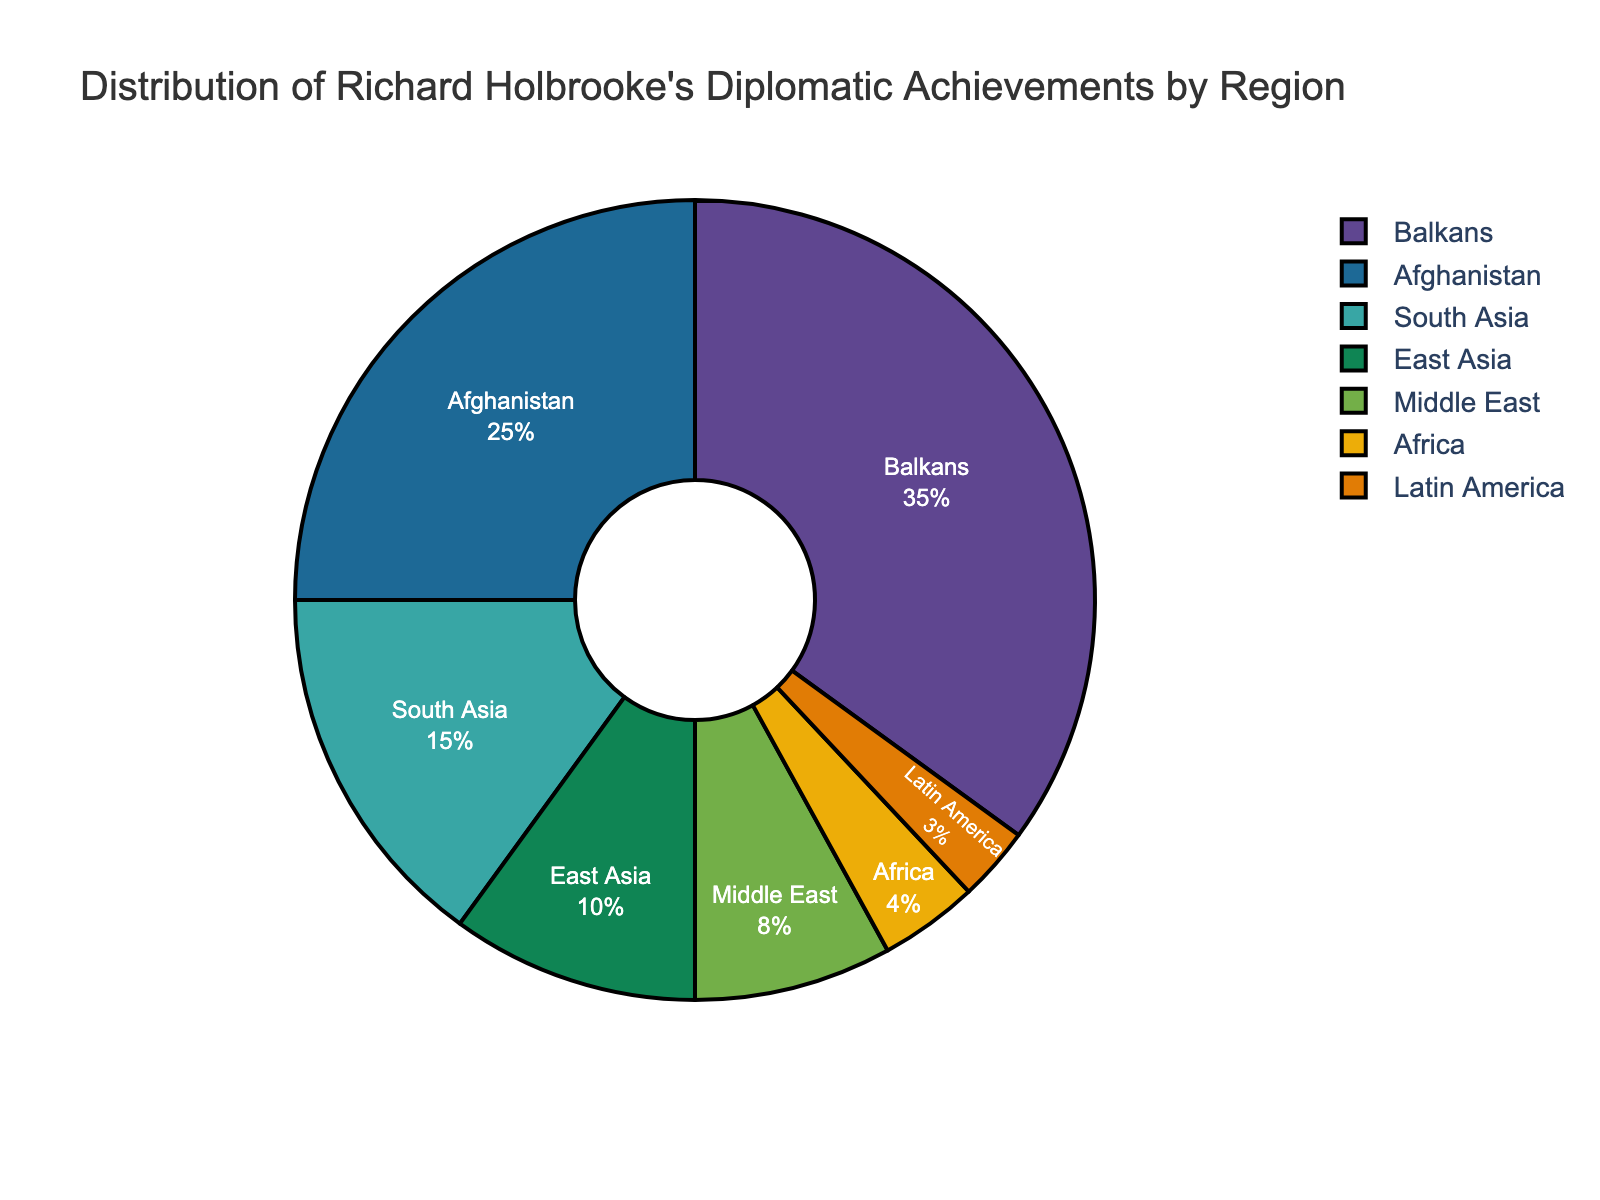what percentage of Richard Holbrooke's diplomatic achievements is in the Balkans? The pie chart shows that the Balkans region is the largest segment, and the percentage is explicitly labeled.
Answer: 35% How does the percentage of achievements in East Asia compare to that in the Middle East? From the pie chart, we see East Asia is labeled with 10% and the Middle East with 8%. 10% is greater than 8%.
Answer: East Asia is greater than Middle East What percentage of Richard Holbrooke's achievements is in Africa and Latin America combined? According to the pie chart, Africa has 4% and Latin America has 3%. Adding these together, we get 4% + 3% = 7%.
Answer: 7% Which region has the smallest percentage of Richard Holbrooke's diplomatic achievements? The pie chart shows all regions with their respective percentages, and Latin America is labeled with the smallest percentage, 3%.
Answer: Latin America Is the sum of the percentages of diplomatic achievements in South Asia and Afghanistan more than 50%? South Asia has 15% and Afghanistan has 25%. Adding these together results in 15% + 25% = 40%, which is less than 50%.
Answer: No What is the difference in the percentage of diplomatic achievements between South Asia and East Asia? From the pie chart, South Asia has 15% and East Asia has 10%. The difference is 15% - 10% = 5%.
Answer: 5% Which two regions combined account for more than half of Richard Holbrooke's diplomatic achievements? The Balkans have 35% and Afghanistan has 25%. Together they sum up to 35% + 25% = 60%, which is more than half.
Answer: Balkans and Afghanistan How much larger is the Balkan's percentage compared to Africa's? The pie chart indicates the Balkans have 35% while Africa has 4%. The difference is 35% - 4% = 31%.
Answer: 31% What region has a percentage just slightly less than a quarter (25%) of the total achievements? The pie chart shows Afghanistan has exactly 25%. The next closest region is South Asia with 15%, which is less than but closest to 25%.
Answer: South Asia Which region in the pie chart is shown in the second largest segment? The pie chart indicates the second largest segment is Afghanistan, shown with 25%.
Answer: Afghanistan 